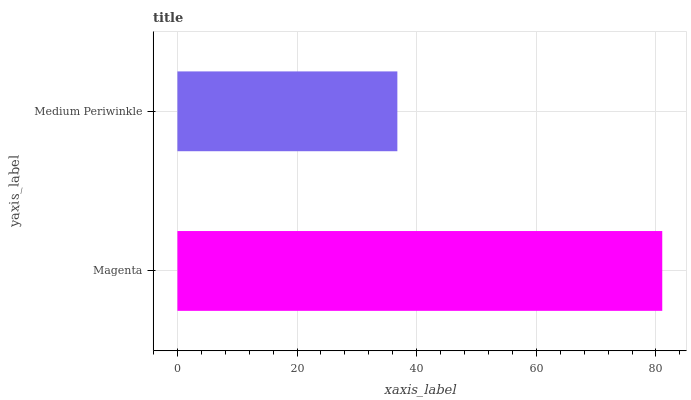Is Medium Periwinkle the minimum?
Answer yes or no. Yes. Is Magenta the maximum?
Answer yes or no. Yes. Is Medium Periwinkle the maximum?
Answer yes or no. No. Is Magenta greater than Medium Periwinkle?
Answer yes or no. Yes. Is Medium Periwinkle less than Magenta?
Answer yes or no. Yes. Is Medium Periwinkle greater than Magenta?
Answer yes or no. No. Is Magenta less than Medium Periwinkle?
Answer yes or no. No. Is Magenta the high median?
Answer yes or no. Yes. Is Medium Periwinkle the low median?
Answer yes or no. Yes. Is Medium Periwinkle the high median?
Answer yes or no. No. Is Magenta the low median?
Answer yes or no. No. 